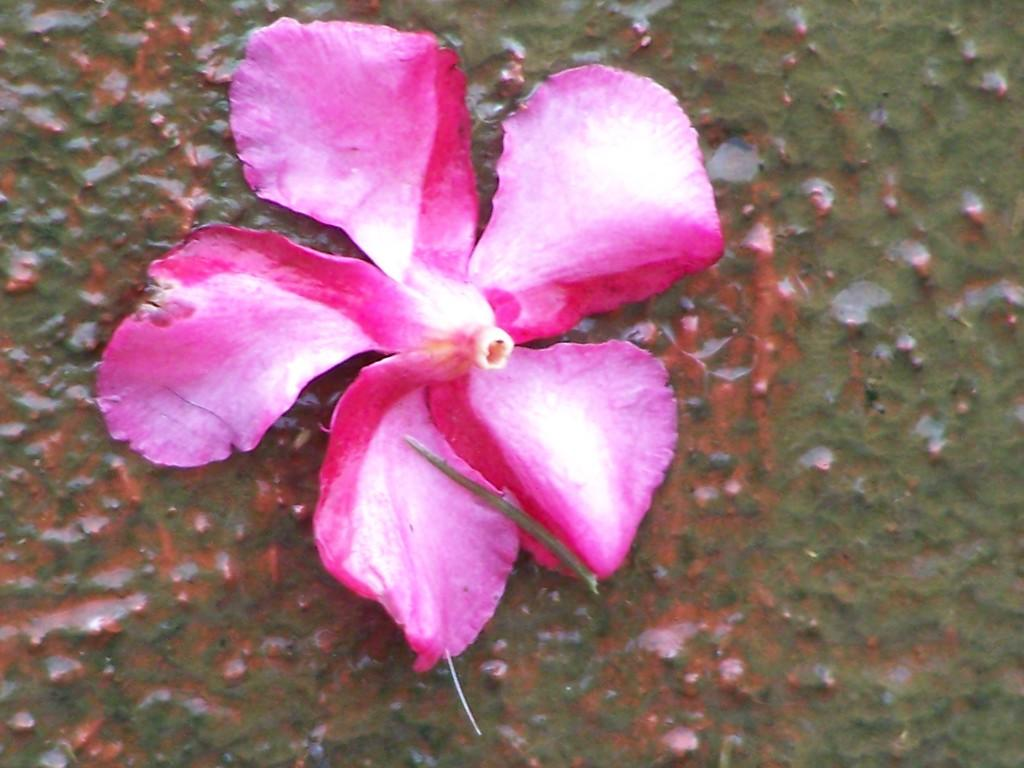What is the main subject of the image? There is a flower in the image. Can you describe the colors of the flower? The flower has pink and white colors. How many cherries are on the flower in the image? There are no cherries present on the flower in the image. Does the flower cause anyone to sneeze in the image? There is no indication in the image that the flower causes anyone to sneeze. 